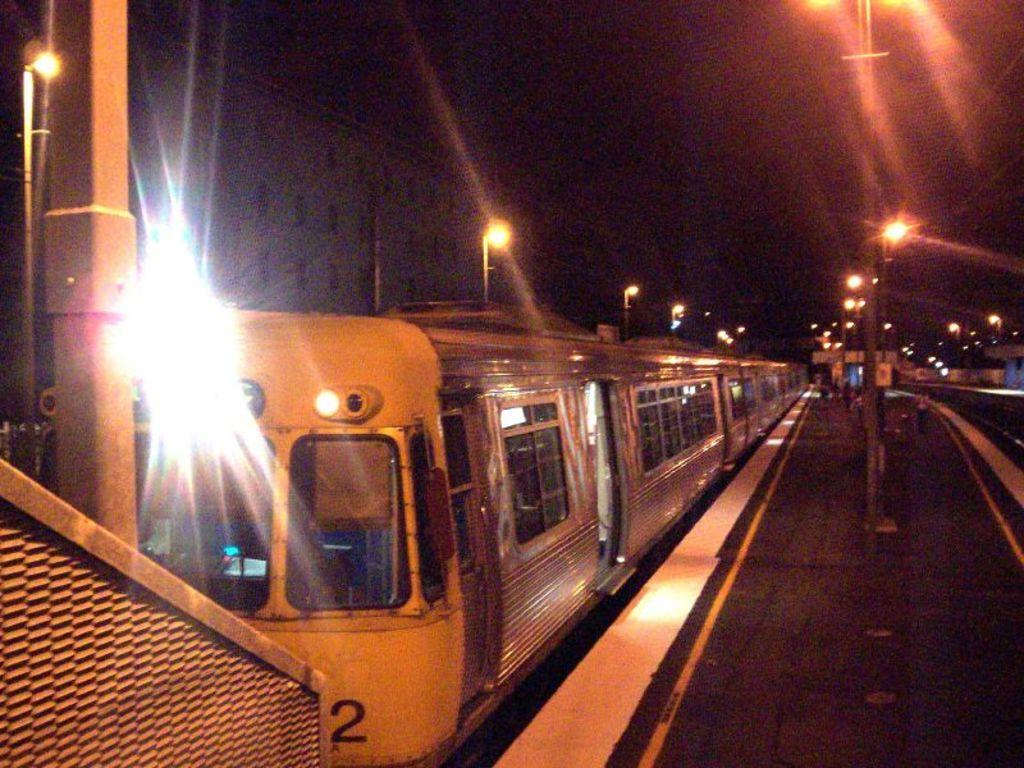<image>
Share a concise interpretation of the image provided. Train parked by the station which has the number 2 on it. 